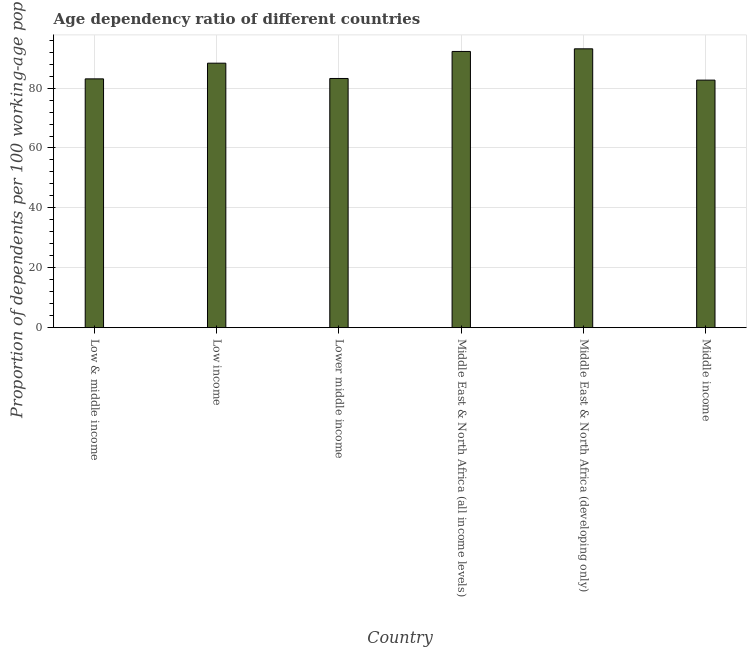Does the graph contain any zero values?
Your answer should be very brief. No. What is the title of the graph?
Make the answer very short. Age dependency ratio of different countries. What is the label or title of the X-axis?
Offer a terse response. Country. What is the label or title of the Y-axis?
Ensure brevity in your answer.  Proportion of dependents per 100 working-age population. What is the age dependency ratio in Low & middle income?
Make the answer very short. 83.09. Across all countries, what is the maximum age dependency ratio?
Provide a succinct answer. 93.12. Across all countries, what is the minimum age dependency ratio?
Keep it short and to the point. 82.67. In which country was the age dependency ratio maximum?
Provide a short and direct response. Middle East & North Africa (developing only). In which country was the age dependency ratio minimum?
Your answer should be very brief. Middle income. What is the sum of the age dependency ratio?
Offer a very short reply. 522.67. What is the difference between the age dependency ratio in Low & middle income and Middle income?
Keep it short and to the point. 0.42. What is the average age dependency ratio per country?
Keep it short and to the point. 87.11. What is the median age dependency ratio?
Your response must be concise. 85.77. What is the ratio of the age dependency ratio in Low & middle income to that in Middle East & North Africa (developing only)?
Your answer should be very brief. 0.89. What is the difference between the highest and the second highest age dependency ratio?
Your response must be concise. 0.88. What is the difference between the highest and the lowest age dependency ratio?
Your response must be concise. 10.46. How many bars are there?
Make the answer very short. 6. Are all the bars in the graph horizontal?
Your answer should be compact. No. What is the Proportion of dependents per 100 working-age population of Low & middle income?
Give a very brief answer. 83.09. What is the Proportion of dependents per 100 working-age population in Low income?
Offer a terse response. 88.32. What is the Proportion of dependents per 100 working-age population in Lower middle income?
Give a very brief answer. 83.22. What is the Proportion of dependents per 100 working-age population in Middle East & North Africa (all income levels)?
Keep it short and to the point. 92.24. What is the Proportion of dependents per 100 working-age population of Middle East & North Africa (developing only)?
Offer a terse response. 93.12. What is the Proportion of dependents per 100 working-age population in Middle income?
Offer a very short reply. 82.67. What is the difference between the Proportion of dependents per 100 working-age population in Low & middle income and Low income?
Give a very brief answer. -5.24. What is the difference between the Proportion of dependents per 100 working-age population in Low & middle income and Lower middle income?
Provide a short and direct response. -0.13. What is the difference between the Proportion of dependents per 100 working-age population in Low & middle income and Middle East & North Africa (all income levels)?
Give a very brief answer. -9.15. What is the difference between the Proportion of dependents per 100 working-age population in Low & middle income and Middle East & North Africa (developing only)?
Provide a succinct answer. -10.03. What is the difference between the Proportion of dependents per 100 working-age population in Low & middle income and Middle income?
Your response must be concise. 0.42. What is the difference between the Proportion of dependents per 100 working-age population in Low income and Lower middle income?
Your answer should be very brief. 5.11. What is the difference between the Proportion of dependents per 100 working-age population in Low income and Middle East & North Africa (all income levels)?
Your answer should be compact. -3.92. What is the difference between the Proportion of dependents per 100 working-age population in Low income and Middle East & North Africa (developing only)?
Make the answer very short. -4.8. What is the difference between the Proportion of dependents per 100 working-age population in Low income and Middle income?
Offer a very short reply. 5.66. What is the difference between the Proportion of dependents per 100 working-age population in Lower middle income and Middle East & North Africa (all income levels)?
Give a very brief answer. -9.02. What is the difference between the Proportion of dependents per 100 working-age population in Lower middle income and Middle East & North Africa (developing only)?
Keep it short and to the point. -9.9. What is the difference between the Proportion of dependents per 100 working-age population in Lower middle income and Middle income?
Ensure brevity in your answer.  0.55. What is the difference between the Proportion of dependents per 100 working-age population in Middle East & North Africa (all income levels) and Middle East & North Africa (developing only)?
Your response must be concise. -0.88. What is the difference between the Proportion of dependents per 100 working-age population in Middle East & North Africa (all income levels) and Middle income?
Offer a terse response. 9.58. What is the difference between the Proportion of dependents per 100 working-age population in Middle East & North Africa (developing only) and Middle income?
Keep it short and to the point. 10.46. What is the ratio of the Proportion of dependents per 100 working-age population in Low & middle income to that in Low income?
Provide a succinct answer. 0.94. What is the ratio of the Proportion of dependents per 100 working-age population in Low & middle income to that in Middle East & North Africa (all income levels)?
Your answer should be compact. 0.9. What is the ratio of the Proportion of dependents per 100 working-age population in Low & middle income to that in Middle East & North Africa (developing only)?
Give a very brief answer. 0.89. What is the ratio of the Proportion of dependents per 100 working-age population in Low & middle income to that in Middle income?
Offer a very short reply. 1. What is the ratio of the Proportion of dependents per 100 working-age population in Low income to that in Lower middle income?
Give a very brief answer. 1.06. What is the ratio of the Proportion of dependents per 100 working-age population in Low income to that in Middle East & North Africa (all income levels)?
Provide a short and direct response. 0.96. What is the ratio of the Proportion of dependents per 100 working-age population in Low income to that in Middle East & North Africa (developing only)?
Your answer should be very brief. 0.95. What is the ratio of the Proportion of dependents per 100 working-age population in Low income to that in Middle income?
Your answer should be very brief. 1.07. What is the ratio of the Proportion of dependents per 100 working-age population in Lower middle income to that in Middle East & North Africa (all income levels)?
Offer a terse response. 0.9. What is the ratio of the Proportion of dependents per 100 working-age population in Lower middle income to that in Middle East & North Africa (developing only)?
Provide a short and direct response. 0.89. What is the ratio of the Proportion of dependents per 100 working-age population in Middle East & North Africa (all income levels) to that in Middle East & North Africa (developing only)?
Give a very brief answer. 0.99. What is the ratio of the Proportion of dependents per 100 working-age population in Middle East & North Africa (all income levels) to that in Middle income?
Make the answer very short. 1.12. What is the ratio of the Proportion of dependents per 100 working-age population in Middle East & North Africa (developing only) to that in Middle income?
Your answer should be very brief. 1.13. 